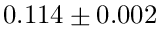<formula> <loc_0><loc_0><loc_500><loc_500>0 . 1 1 4 \pm 0 . 0 0 2</formula> 